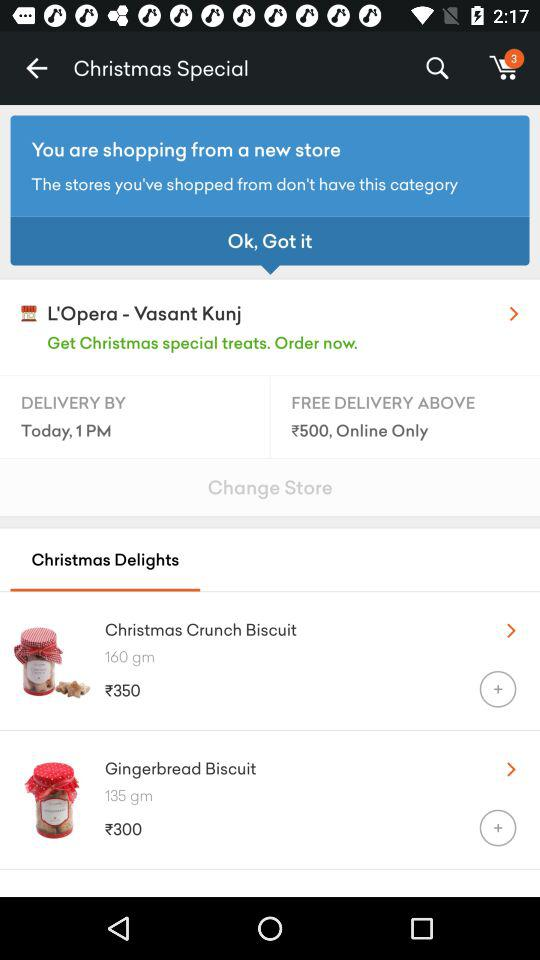How many things are in the cart? There are 3 things in the cart. 